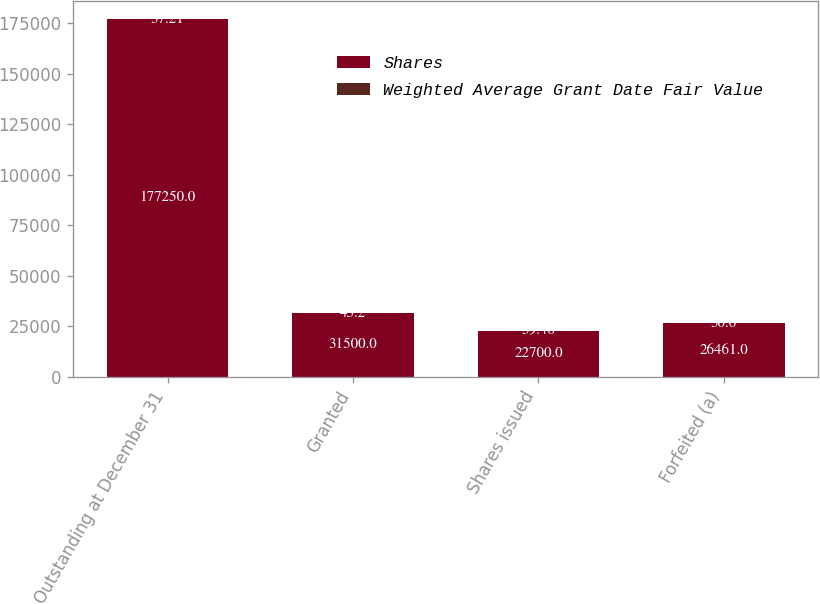<chart> <loc_0><loc_0><loc_500><loc_500><stacked_bar_chart><ecel><fcel>Outstanding at December 31<fcel>Granted<fcel>Shares issued<fcel>Forfeited (a)<nl><fcel>Shares<fcel>177250<fcel>31500<fcel>22700<fcel>26461<nl><fcel>Weighted Average Grant Date Fair Value<fcel>37.21<fcel>43.2<fcel>39.46<fcel>30.6<nl></chart> 